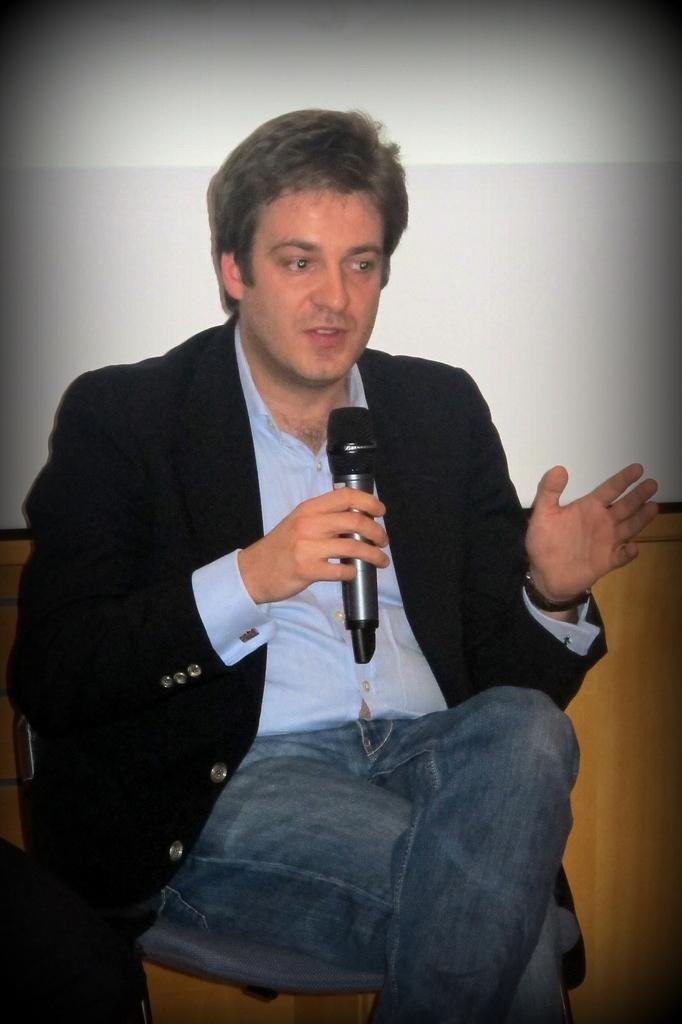Who is the main subject in the image? There is a man in the image. What is the man doing in the image? The man is sitting on a chair and holding a microphone in his hand. What can be seen in the background of the image? There is a wall in the background of the image. Where is the sink located in the image? There is no sink present in the image. What type of bread is the man holding in his hand? The man is not holding any bread in his hand; he is holding a microphone. 